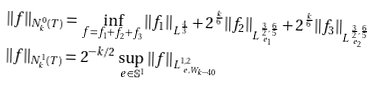Convert formula to latex. <formula><loc_0><loc_0><loc_500><loc_500>\| f \| _ { N _ { k } ^ { 0 } ( T ) } = & \ \inf _ { f = f _ { 1 } + f _ { 2 } + f _ { 3 } } \| f _ { 1 } \| _ { L ^ { \frac { 4 } { 3 } } } + 2 ^ { \frac { k } 6 } \| f _ { 2 } \| _ { L ^ { \frac { 3 } { 2 } , \frac { 6 } { 5 } } _ { \ e _ { 1 } } } + 2 ^ { \frac { k } 6 } \| f _ { 3 } \| _ { L ^ { \frac { 3 } { 2 } , \frac { 6 } { 5 } } _ { \ e _ { 2 } } } \\ \| f \| _ { N _ { k } ^ { 1 } ( T ) } = & \ 2 ^ { - k / 2 } \sup _ { \ e \in \mathbb { S } ^ { 1 } } \| f \| _ { L ^ { 1 , 2 } _ { \ e , W _ { k - 4 0 } } }</formula> 